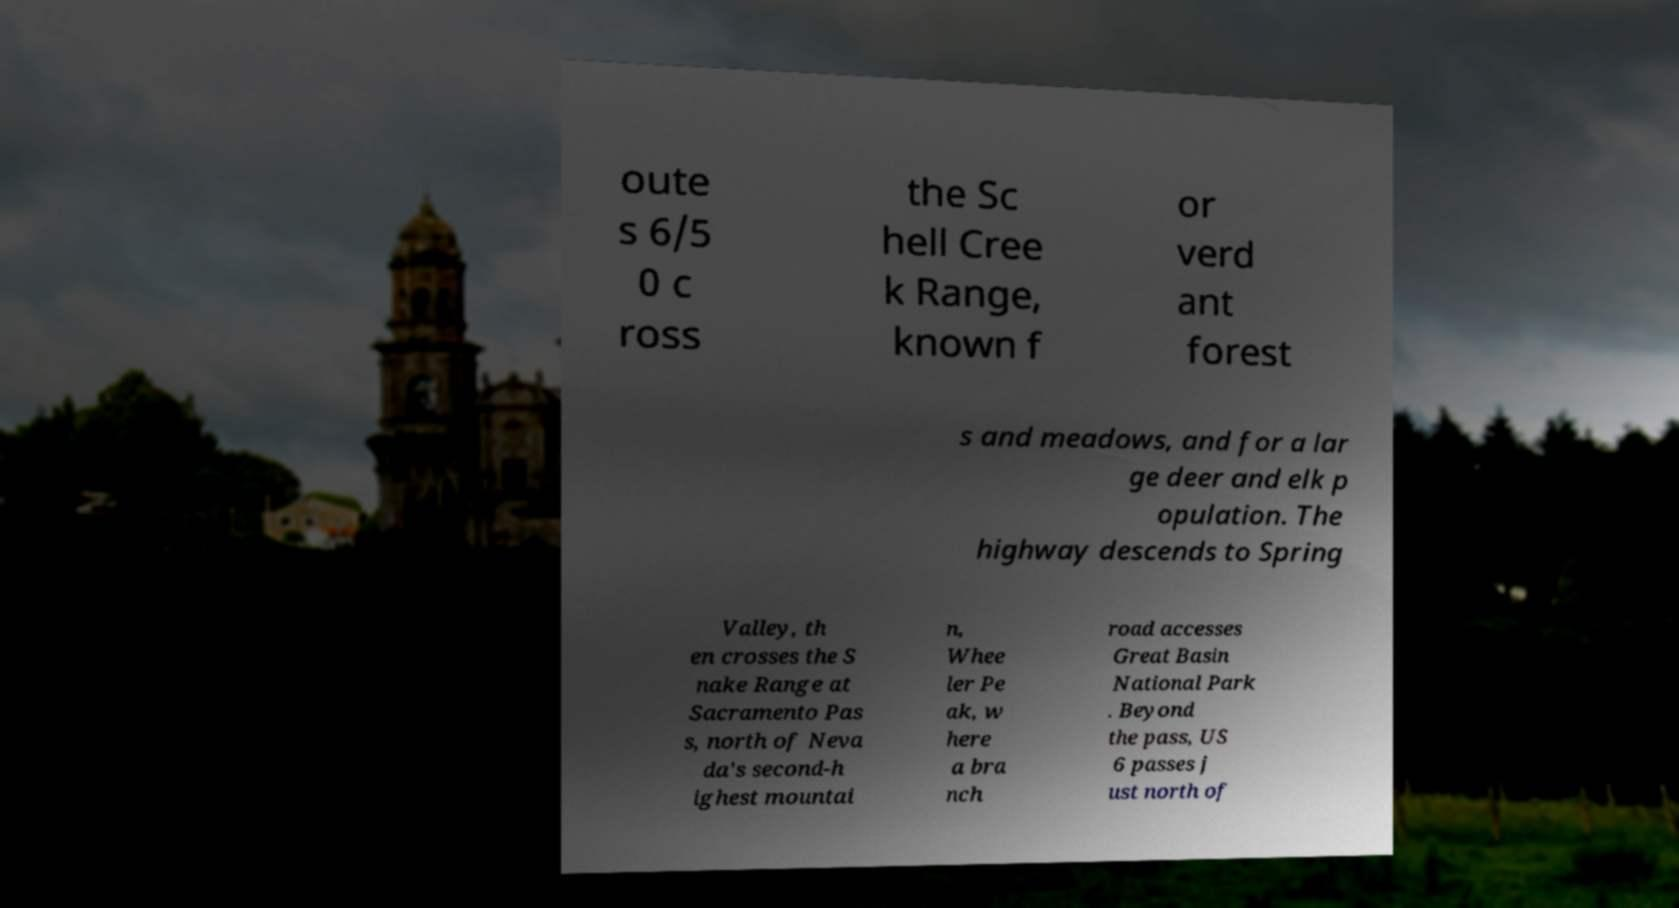Please identify and transcribe the text found in this image. oute s 6/5 0 c ross the Sc hell Cree k Range, known f or verd ant forest s and meadows, and for a lar ge deer and elk p opulation. The highway descends to Spring Valley, th en crosses the S nake Range at Sacramento Pas s, north of Neva da's second-h ighest mountai n, Whee ler Pe ak, w here a bra nch road accesses Great Basin National Park . Beyond the pass, US 6 passes j ust north of 